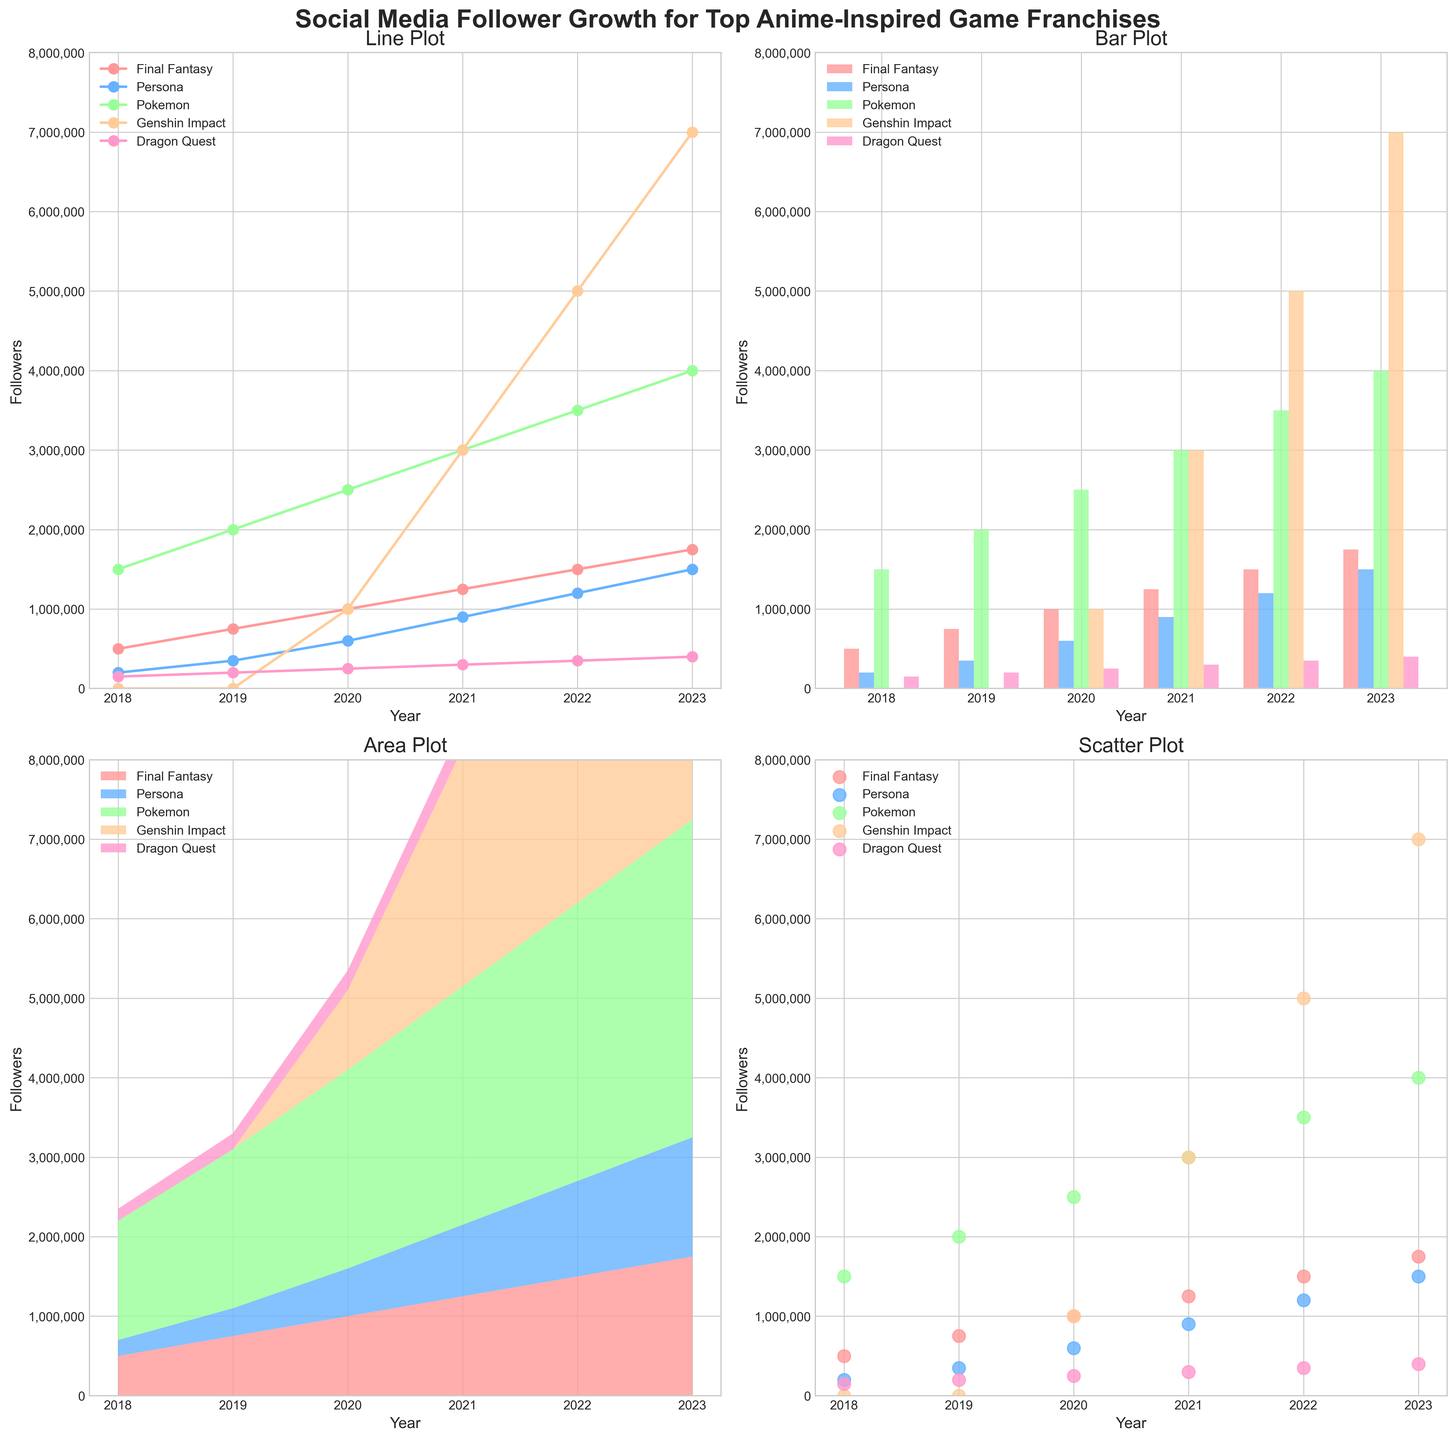How does the number of followers for "Final Fantasy" change from 2018 to 2023 in the line plot? The line plot shows a steady increase for "Final Fantasy" from 500,000 in 2018 to 1,750,000 in 2023. The data points are marked with a continuous, upward-trending line.
Answer: 500,000 to 1,750,000 Which game franchise had zero followers before 2020 in the area plot? The area plot shows stacked regions representing each game's followers. The "Genshin Impact" region starts at 2020, indicating it had zero followers before that year.
Answer: Genshin Impact Looking at the bar plot, which game had the most significant increase in followers between 2020 and 2021? In the bar plot, the height of the bars for "Genshin Impact" between 2020 and 2021 shows the most significant increase compared to other games.
Answer: Genshin Impact Which year did "Persona" surpass 1,000,000 followers in the scatter plot? The scatter plot shows data points for each game's yearly followers. The "Persona" plot surpasses the 1,000,000 mark in the year 2022.
Answer: 2022 In the line plot, which game franchise had the smallest number of followers in 2023? Comparing the end points of the lines in the line plot for the year 2023, "Dragon Quest" has the smallest number of followers at 400,000.
Answer: Dragon Quest By looking at the area plot, which game franchise has consistently increased its followers every year? Observing the stacked areas in the area plot, both "Final Fantasy" and "Persona" show a consistent yearly increase without any drop.
Answer: Final Fantasy and Persona Using the bar plot, compare the follower count of "Pokemon" and "Genshin Impact" in 2022. Which one had more followers? The bar plot for 2022 shows "Genshin Impact" bar surpassing the "Pokemon" bar, indicating it had more followers.
Answer: Genshin Impact In the scatter plot, which year did "Final Fantasy" reach 1,000,000 followers? The scatter plot shows a point for "Final Fantasy" at 1,000,000 followers in the year 2020.
Answer: 2020 